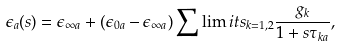<formula> <loc_0><loc_0><loc_500><loc_500>\epsilon _ { a } ( s ) = \epsilon _ { \infty a } + ( \epsilon _ { 0 a } - \epsilon _ { \infty a } ) \sum \lim i t s _ { k = 1 , 2 } \frac { g _ { k } } { 1 + s \tau _ { k a } } ,</formula> 